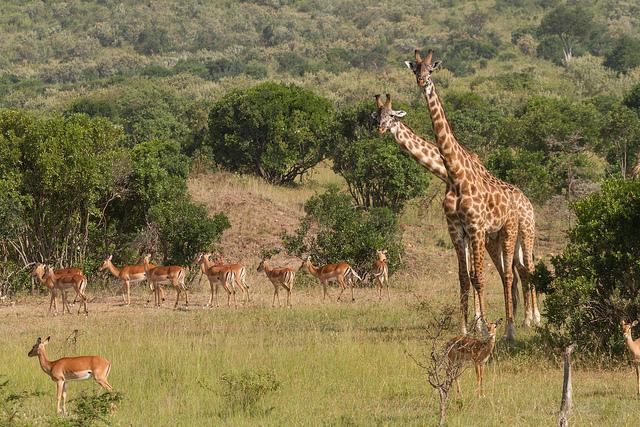Are these animals behind a fence?
Quick response, please. No. How many giraffes are there?
Be succinct. 2. Is there a body of water nearby?
Answer briefly. No. Is there more than one type of animal in the scene?
Keep it brief. Yes. 